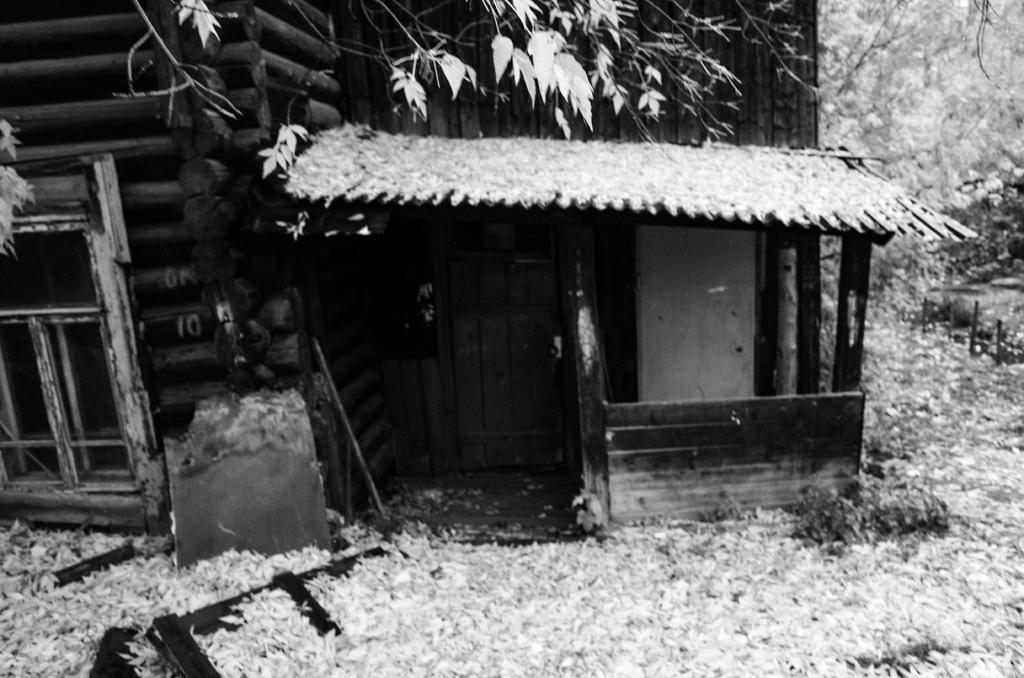Describe this image in one or two sentences. In this picture we can see a window, door, walls, some objects and in the background we can see trees. 